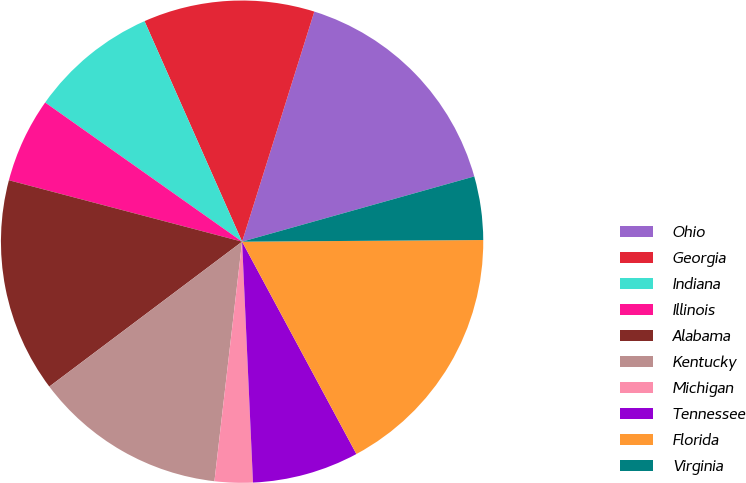Convert chart to OTSL. <chart><loc_0><loc_0><loc_500><loc_500><pie_chart><fcel>Ohio<fcel>Georgia<fcel>Indiana<fcel>Illinois<fcel>Alabama<fcel>Kentucky<fcel>Michigan<fcel>Tennessee<fcel>Florida<fcel>Virginia<nl><fcel>15.8%<fcel>11.47%<fcel>8.58%<fcel>5.69%<fcel>14.36%<fcel>12.91%<fcel>2.55%<fcel>7.14%<fcel>17.25%<fcel>4.25%<nl></chart> 